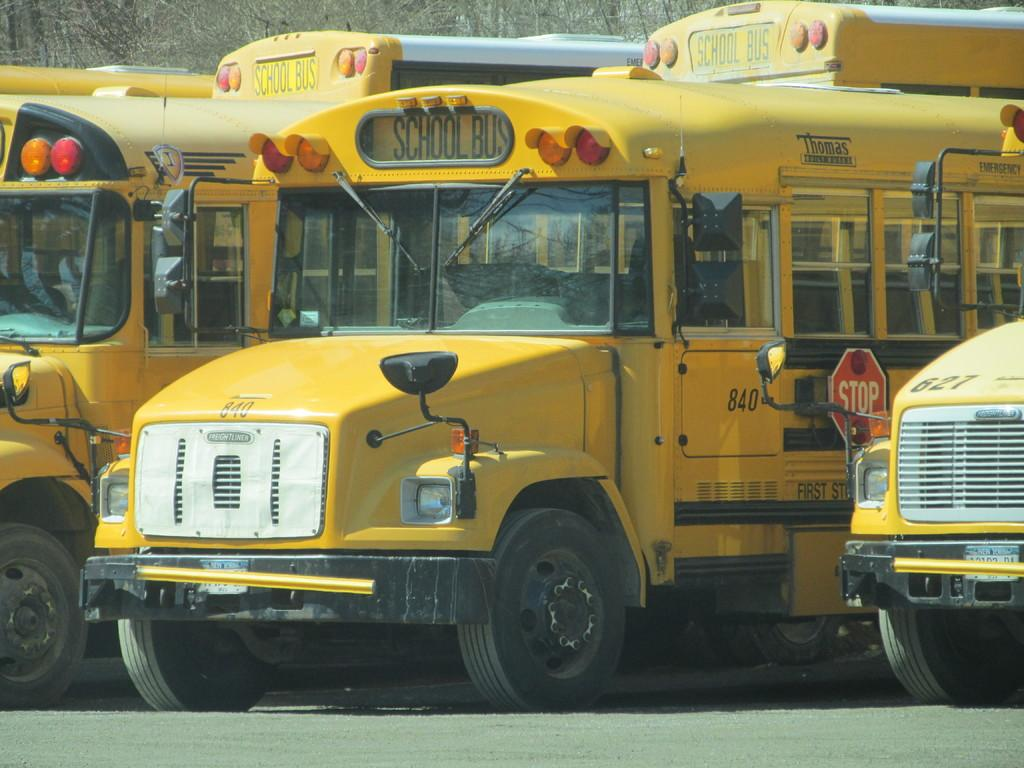How many school buses are visible in the image? There are three school buses in the image. What color are the school buses? The school buses are yellow in color. What type of hat is the scarecrow wearing in the image? There is no scarecrow or hat present in the image; it features three yellow school buses. 